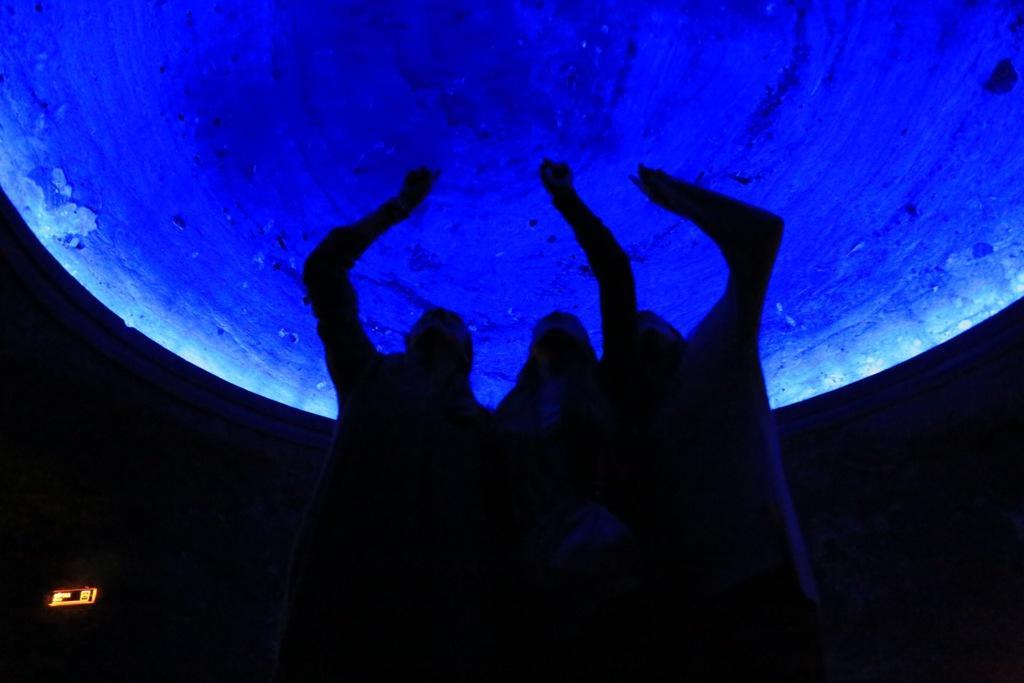Can you describe this image briefly? In this image there are three people standing. Above them there is a circular object. They are touching the object. The image is dark. 